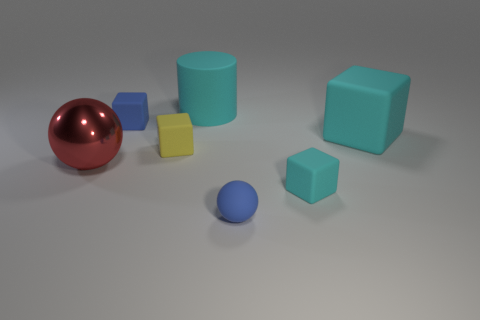Is there any sense of motion or activity captured in the image? The image appears static with all objects at rest. There's no indication of motion or activity; the objects are simply resting on the surface, dormant and undisturbed. 